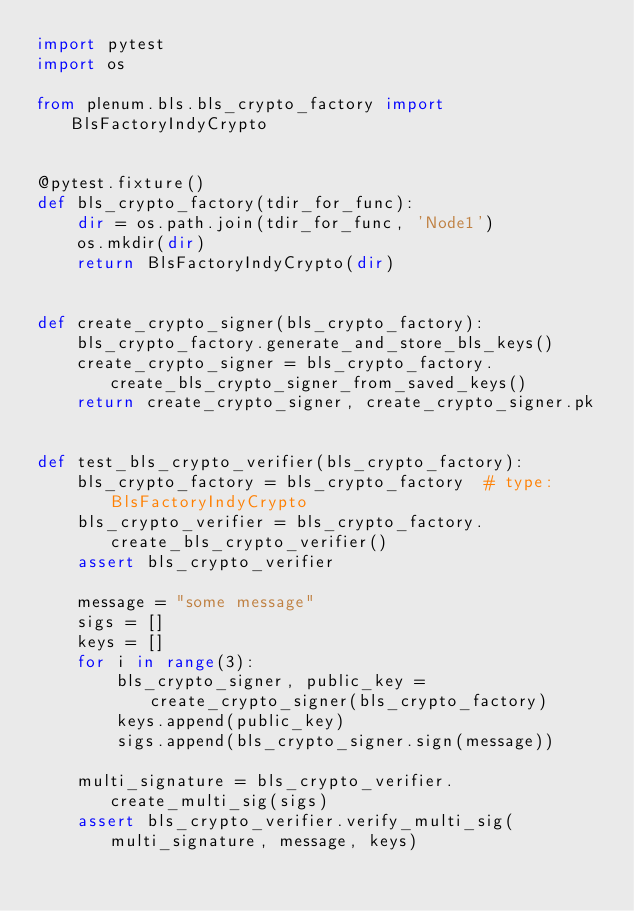Convert code to text. <code><loc_0><loc_0><loc_500><loc_500><_Python_>import pytest
import os

from plenum.bls.bls_crypto_factory import BlsFactoryIndyCrypto


@pytest.fixture()
def bls_crypto_factory(tdir_for_func):
    dir = os.path.join(tdir_for_func, 'Node1')
    os.mkdir(dir)
    return BlsFactoryIndyCrypto(dir)


def create_crypto_signer(bls_crypto_factory):
    bls_crypto_factory.generate_and_store_bls_keys()
    create_crypto_signer = bls_crypto_factory.create_bls_crypto_signer_from_saved_keys()
    return create_crypto_signer, create_crypto_signer.pk


def test_bls_crypto_verifier(bls_crypto_factory):
    bls_crypto_factory = bls_crypto_factory  # type: BlsFactoryIndyCrypto
    bls_crypto_verifier = bls_crypto_factory.create_bls_crypto_verifier()
    assert bls_crypto_verifier

    message = "some message"
    sigs = []
    keys = []
    for i in range(3):
        bls_crypto_signer, public_key = create_crypto_signer(bls_crypto_factory)
        keys.append(public_key)
        sigs.append(bls_crypto_signer.sign(message))

    multi_signature = bls_crypto_verifier.create_multi_sig(sigs)
    assert bls_crypto_verifier.verify_multi_sig(multi_signature, message, keys)
</code> 